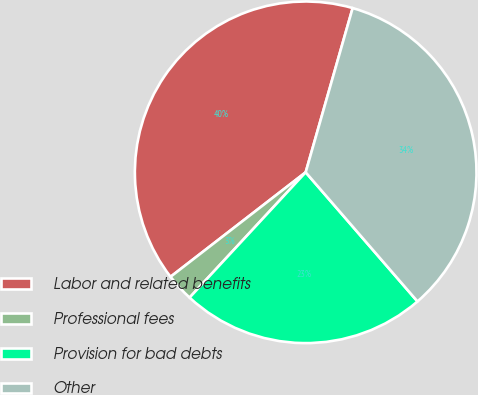Convert chart to OTSL. <chart><loc_0><loc_0><loc_500><loc_500><pie_chart><fcel>Labor and related benefits<fcel>Professional fees<fcel>Provision for bad debts<fcel>Other<nl><fcel>39.91%<fcel>2.63%<fcel>23.25%<fcel>34.21%<nl></chart> 